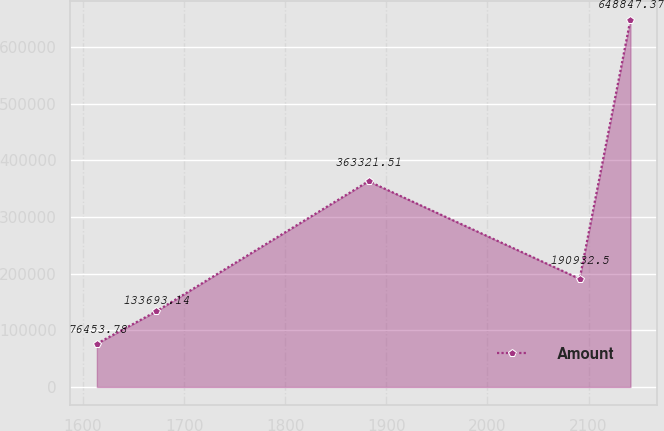Convert chart to OTSL. <chart><loc_0><loc_0><loc_500><loc_500><line_chart><ecel><fcel>Amount<nl><fcel>1613.65<fcel>76453.8<nl><fcel>1672.59<fcel>133693<nl><fcel>1882.32<fcel>363322<nl><fcel>2091.15<fcel>190932<nl><fcel>2141.41<fcel>648847<nl></chart> 